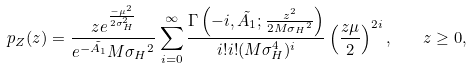<formula> <loc_0><loc_0><loc_500><loc_500>p _ { Z } ( z ) = \frac { z e ^ { \frac { - \mu ^ { 2 } } { 2 \sigma _ { H } ^ { 2 } } } } { e ^ { - \tilde { A _ { 1 } } } M { \sigma _ { H } } ^ { 2 } } \sum _ { i = 0 } ^ { \infty } \frac { \Gamma \left ( - i , \tilde { A _ { 1 } } ; \frac { z ^ { 2 } } { 2 M { \sigma _ { H } } ^ { 2 } } \right ) } { i ! i ! ( M \sigma _ { H } ^ { 4 } ) ^ { i } } \left ( \frac { z \mu } { 2 } \right ) ^ { 2 i } , \quad z \geq 0 ,</formula> 